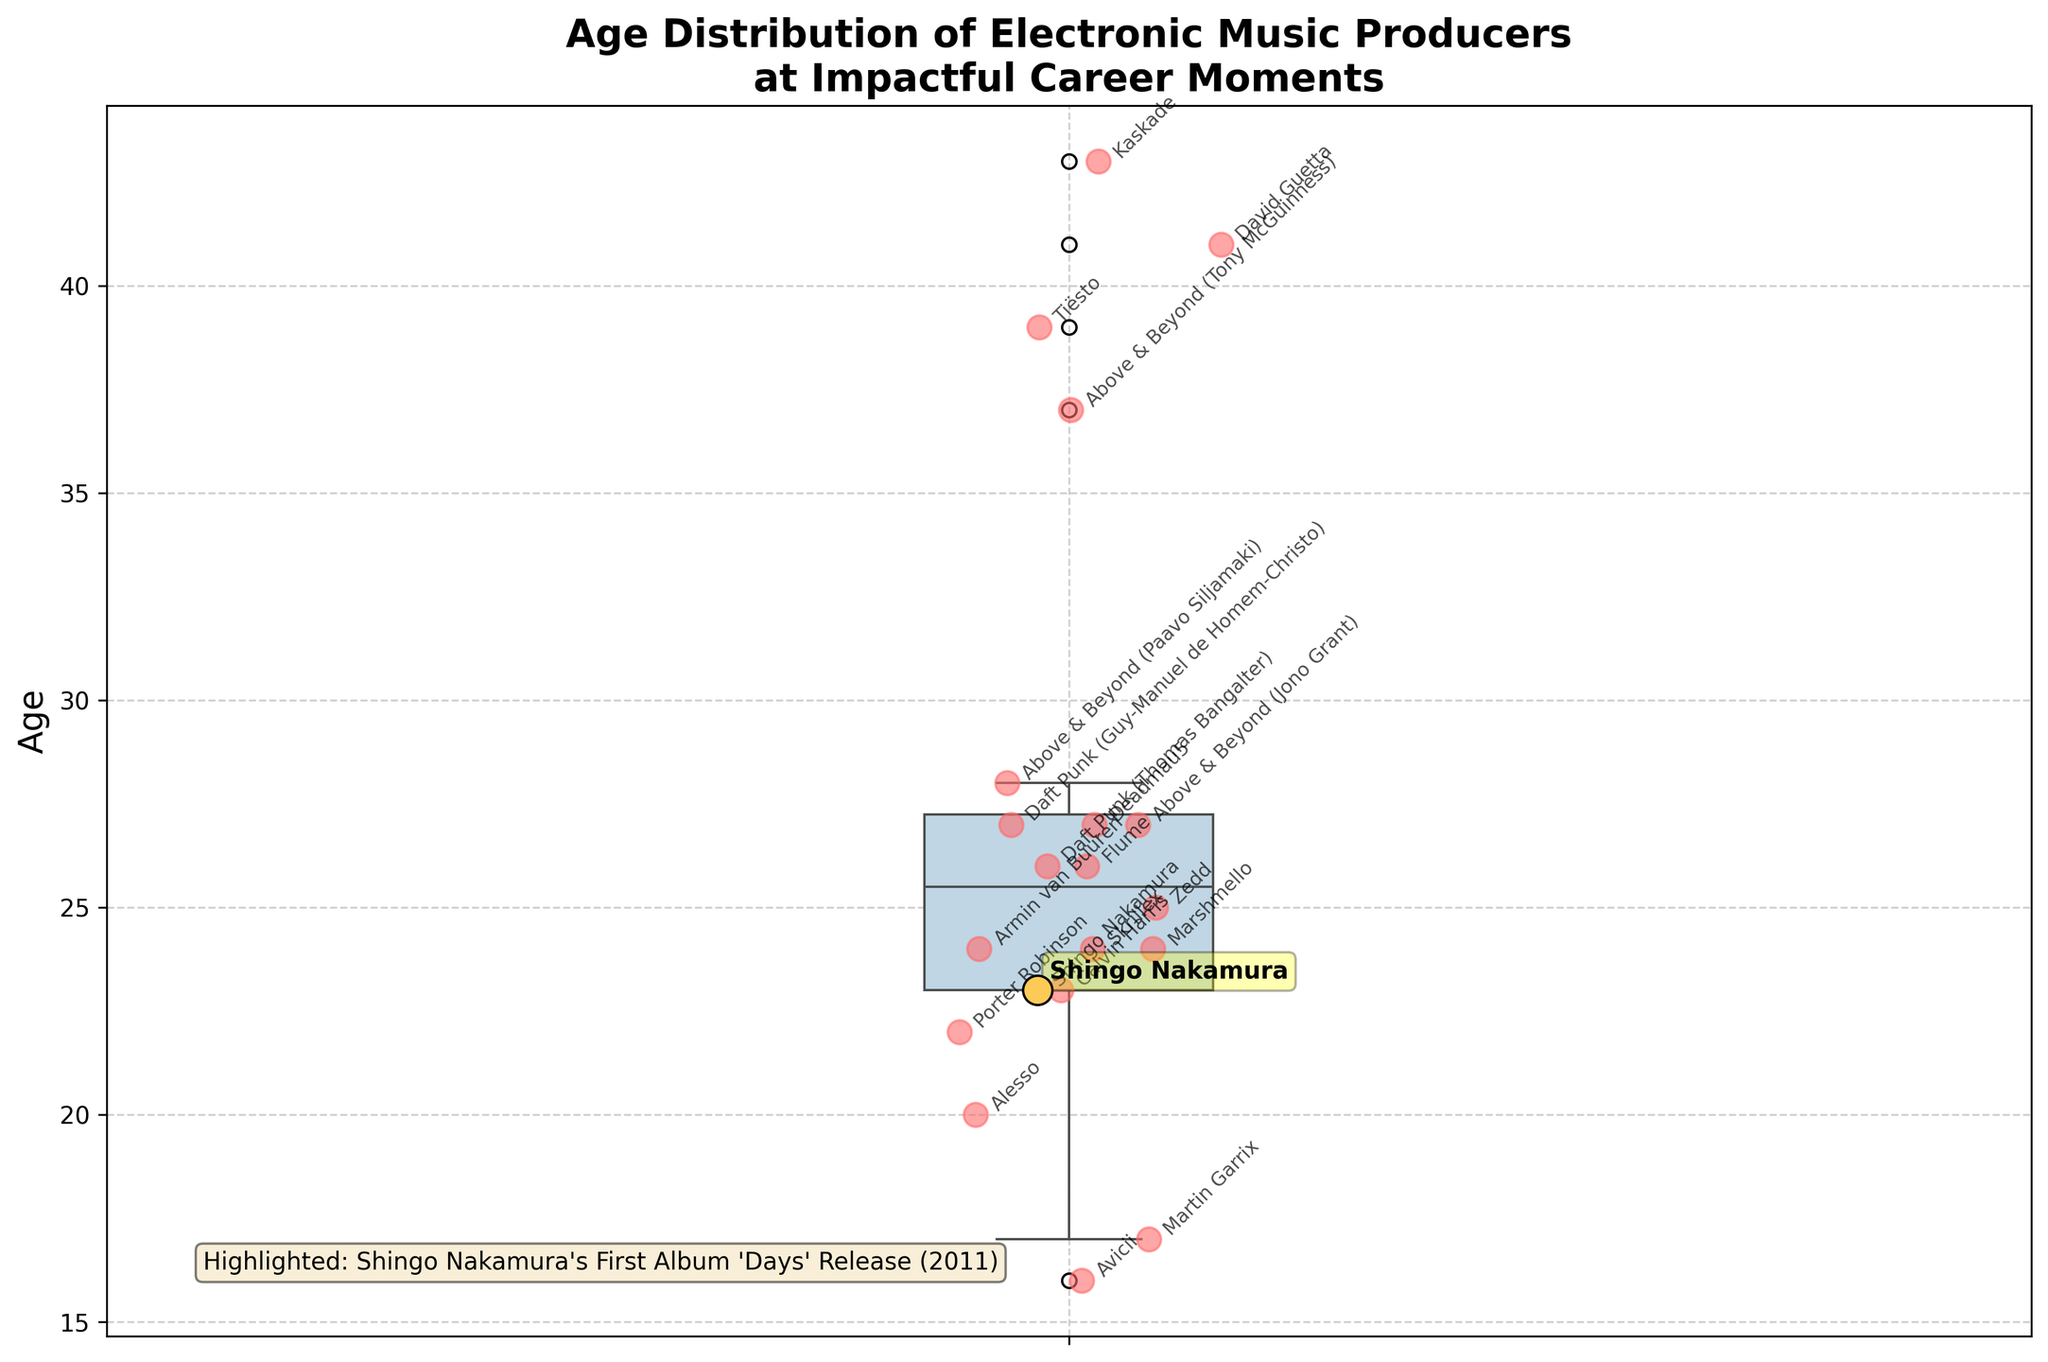What's the title of the plot? The title of the plot is usually found at the top of the figure, offering a summary about the data being visualized. In this case, it reads: "Age Distribution of Electronic Music Producers at Impactful Career Moments".
Answer: Age Distribution of Electronic Music Producers at Impactful Career Moments What's the y-axis label in the plot? The y-axis label is found along the vertical axis of the plot and typically describes the type of data being shown. Here, it is labeled as "Age".
Answer: Age How is Shingo Nakamura highlighted in the plot? In the plot, Shingo Nakamura is highlighted using a special color and a text annotation. Specifically, a scatter point for Shingo Nakamura is colored differently (yellow), has a larger size, and is annotated with his name along with an explanatory text box.
Answer: Yellow scatter point with annotation Who has the lowest age at their impactful career moment? To find the producer with the lowest age, observe the scatter points and the respective annotations. The point at the lowest position on the y-axis represents the youngest age, which is for Martin Garrix.
Answer: Martin Garrix Who are the producers who had impactful moments around the age of 35? Look at the scatter points around the age value of 35, and check the annotations for the corresponding producers' names. Shingo Nakamura and Skrillex had impactful moments at around age 35.
Answer: Shingo Nakamura and Skrillex Which producer had an impactful career moment most recently? Recently impactful moments can be inferred from the additional textual information in the box, or annotations that explicitly mention years. Marshmello's debut single 'Alone' was released in 2016, the latest impactful event in the displayed dataset.
Answer: Marshmello What is the range of ages at impactful career moments shown in the plot? To determine the range, identify the minimum and maximum age values from the scatter points and annotations. The youngest is Martin Garrix at age 27, and the oldest is David Guetta at age 55. Subtract the minimum from the maximum value to find the range: 55 - 27 = 28.
Answer: 28 Which producer or producers had an impactful career moment around the age of 48? Look for scatter points marked around the age of 48 and read the associated annotations. Daft Punk (Thomas Bangalter) had an impactful moment at age 48.
Answer: Daft Punk (Thomas Bangalter) What is the median age at impactful career moments? The median is the middle value of the ordered dataset. To find the median, note the central point of the box plot's interquartile range, which is generally marked in the middle of the box. The median age appears to be around 35.
Answer: 35 